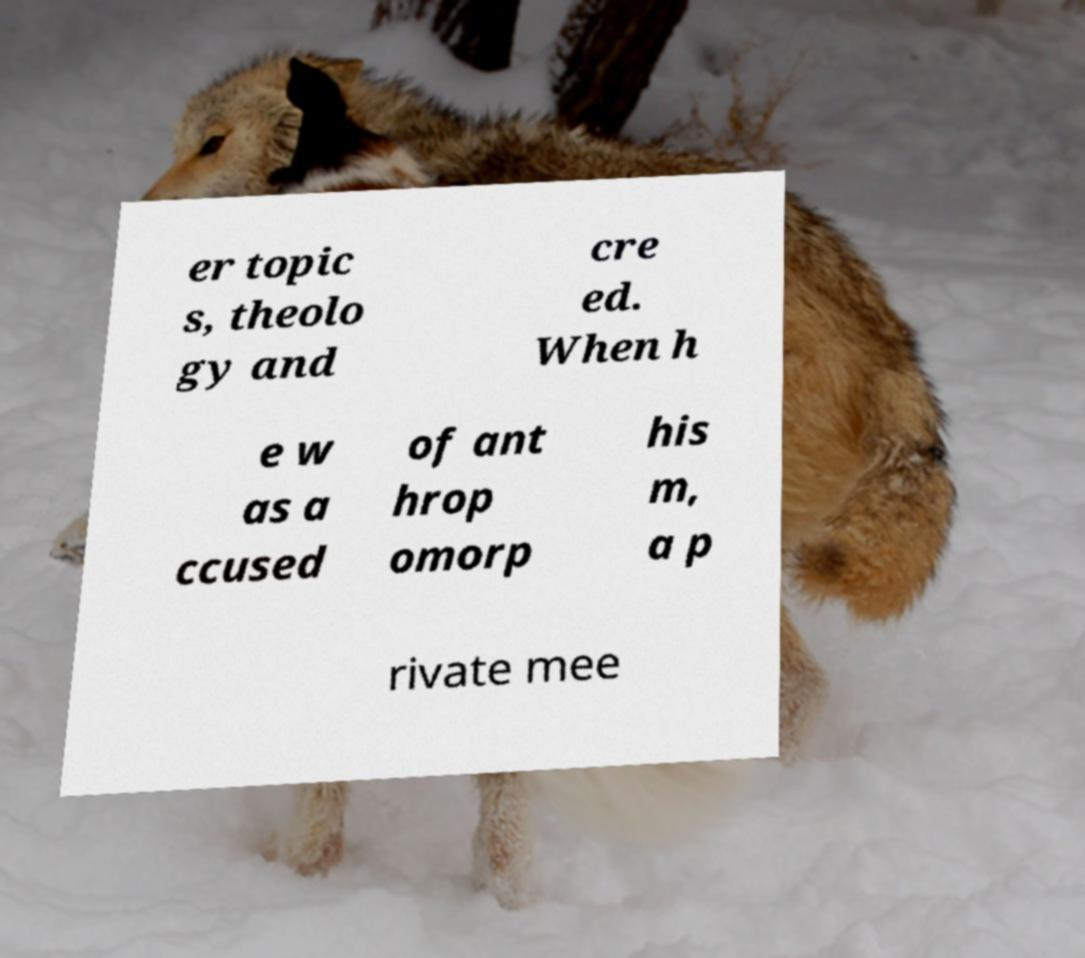What messages or text are displayed in this image? I need them in a readable, typed format. er topic s, theolo gy and cre ed. When h e w as a ccused of ant hrop omorp his m, a p rivate mee 